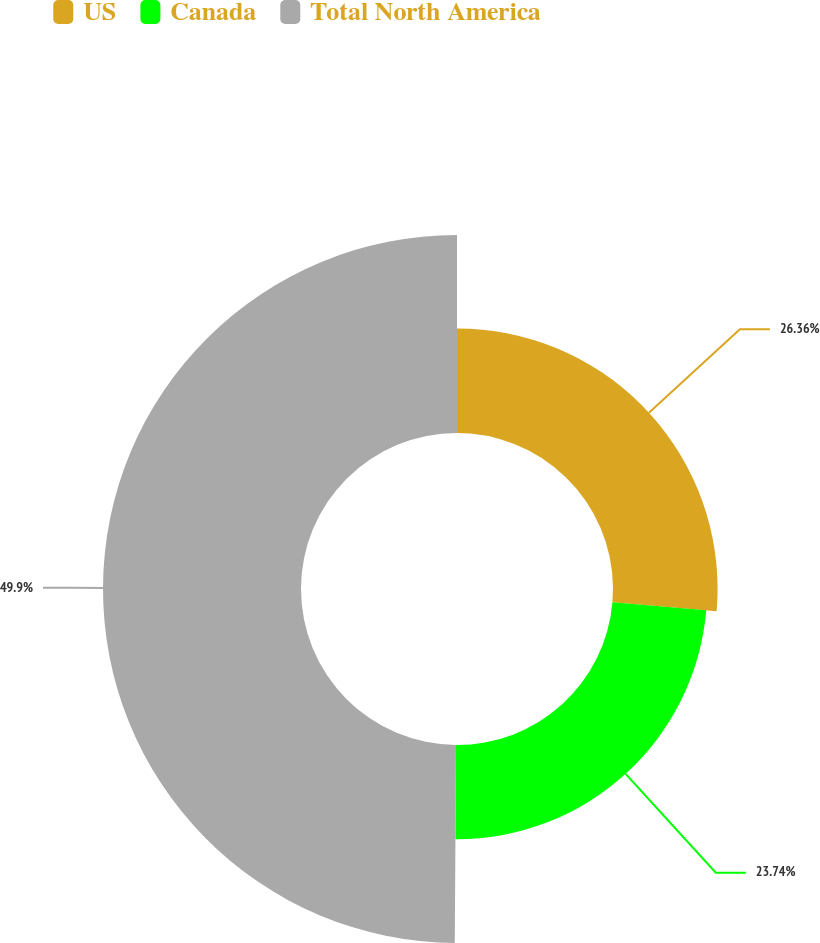Convert chart. <chart><loc_0><loc_0><loc_500><loc_500><pie_chart><fcel>US<fcel>Canada<fcel>Total North America<nl><fcel>26.36%<fcel>23.74%<fcel>49.9%<nl></chart> 